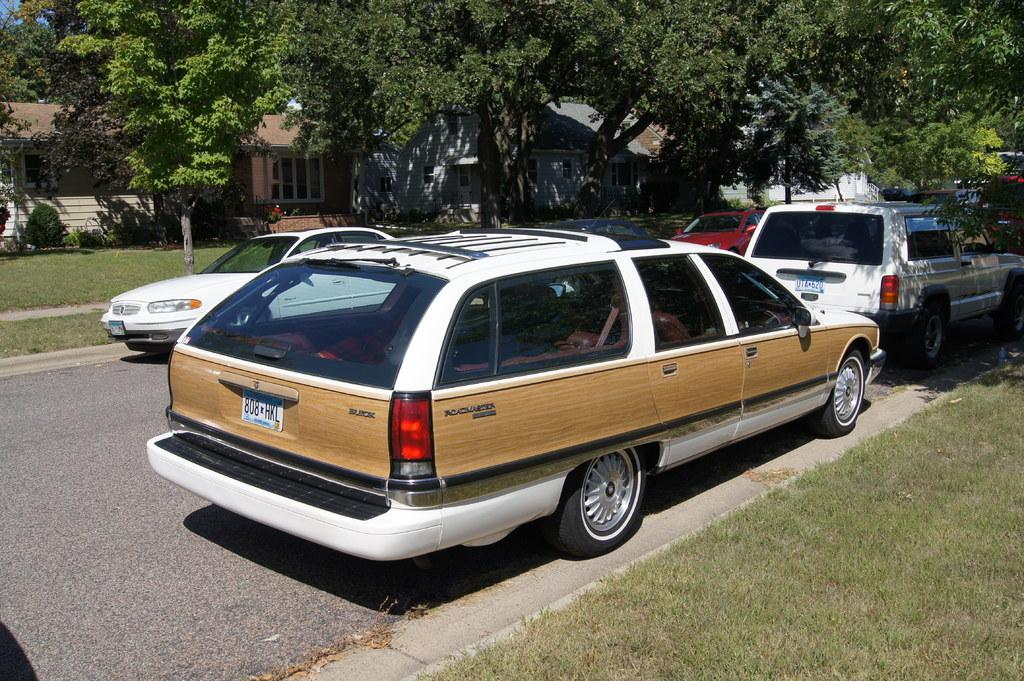<image>
Describe the image concisely. A wood grain and white Buick parked at the curb. 